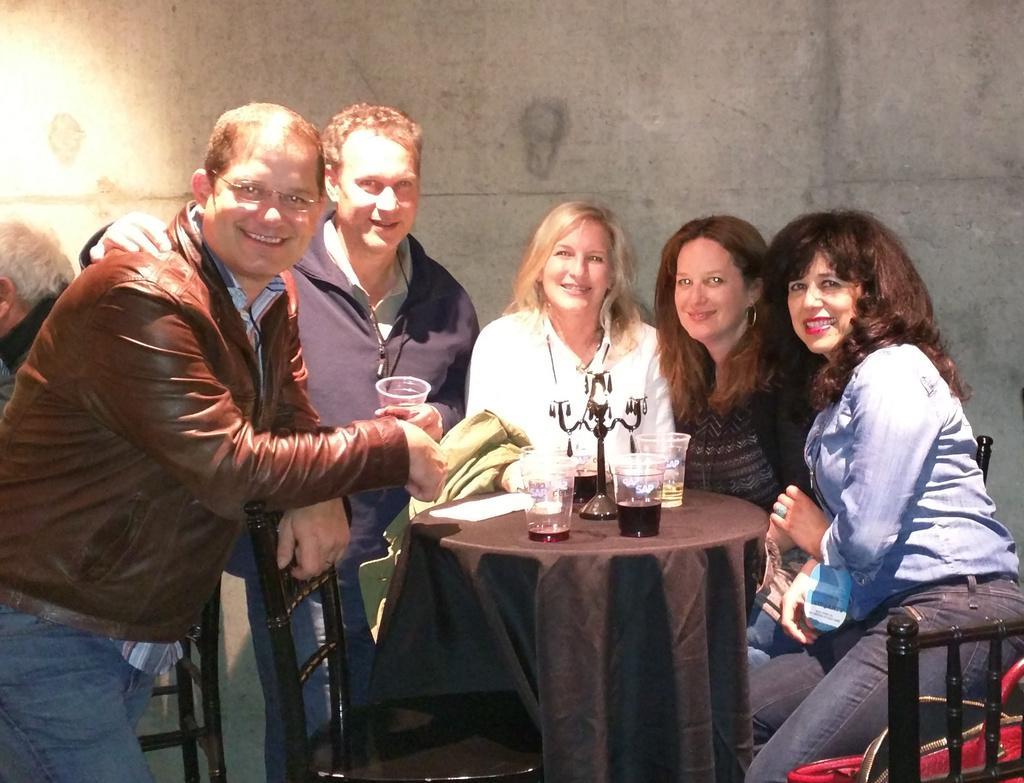Can you describe this image briefly? In the middle of the image there is a table, On the table there are some glasses. Surrounding the table there are some chairs and there are some persons and they are smiling. Behind them there is a wall. 